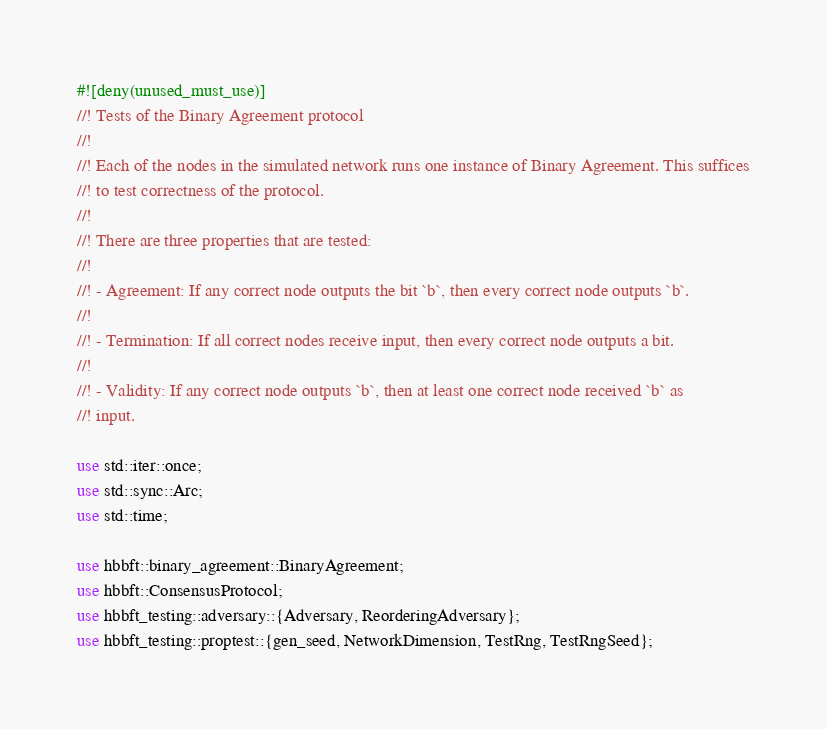<code> <loc_0><loc_0><loc_500><loc_500><_Rust_>#![deny(unused_must_use)]
//! Tests of the Binary Agreement protocol
//!
//! Each of the nodes in the simulated network runs one instance of Binary Agreement. This suffices
//! to test correctness of the protocol.
//!
//! There are three properties that are tested:
//!
//! - Agreement: If any correct node outputs the bit `b`, then every correct node outputs `b`.
//!
//! - Termination: If all correct nodes receive input, then every correct node outputs a bit.
//!
//! - Validity: If any correct node outputs `b`, then at least one correct node received `b` as
//! input.

use std::iter::once;
use std::sync::Arc;
use std::time;

use hbbft::binary_agreement::BinaryAgreement;
use hbbft::ConsensusProtocol;
use hbbft_testing::adversary::{Adversary, ReorderingAdversary};
use hbbft_testing::proptest::{gen_seed, NetworkDimension, TestRng, TestRngSeed};</code> 